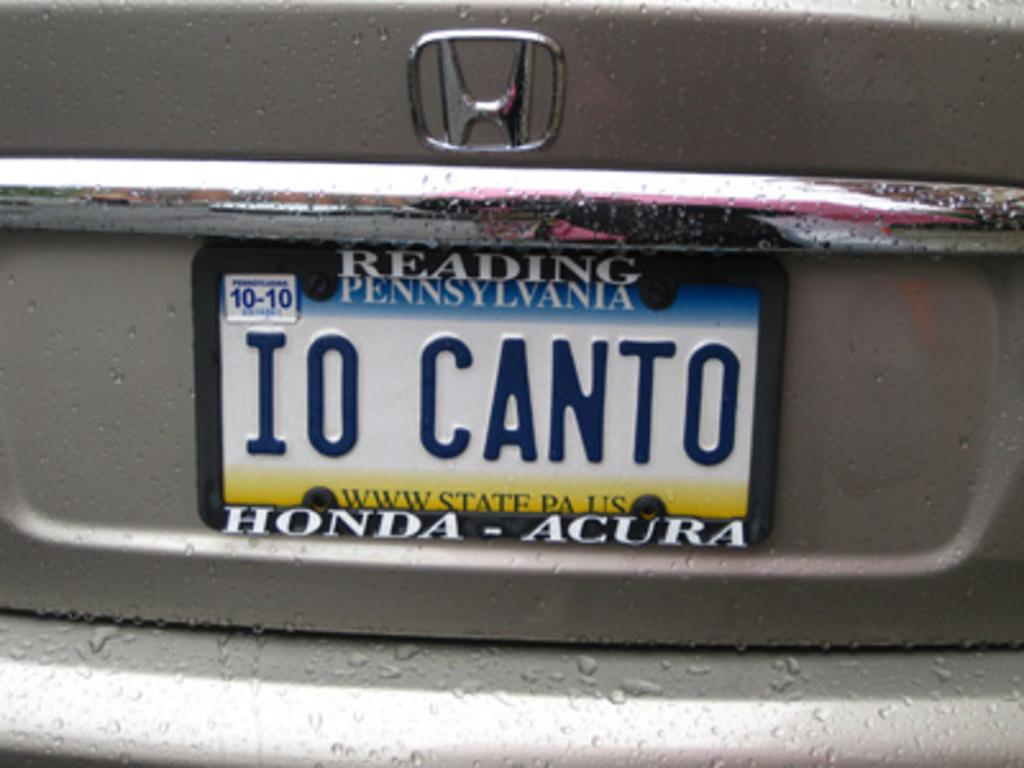What is the main subject of the image? The main subject of the image is a vehicle. Can you describe any specific features of the vehicle? Yes, the vehicle has a number plate and a logo. What type of chin can be seen on the vehicle in the image? There is no chin present on the vehicle in the image. Is there any smoke coming out of the vehicle in the image? The image does not show any smoke coming out of the vehicle. 